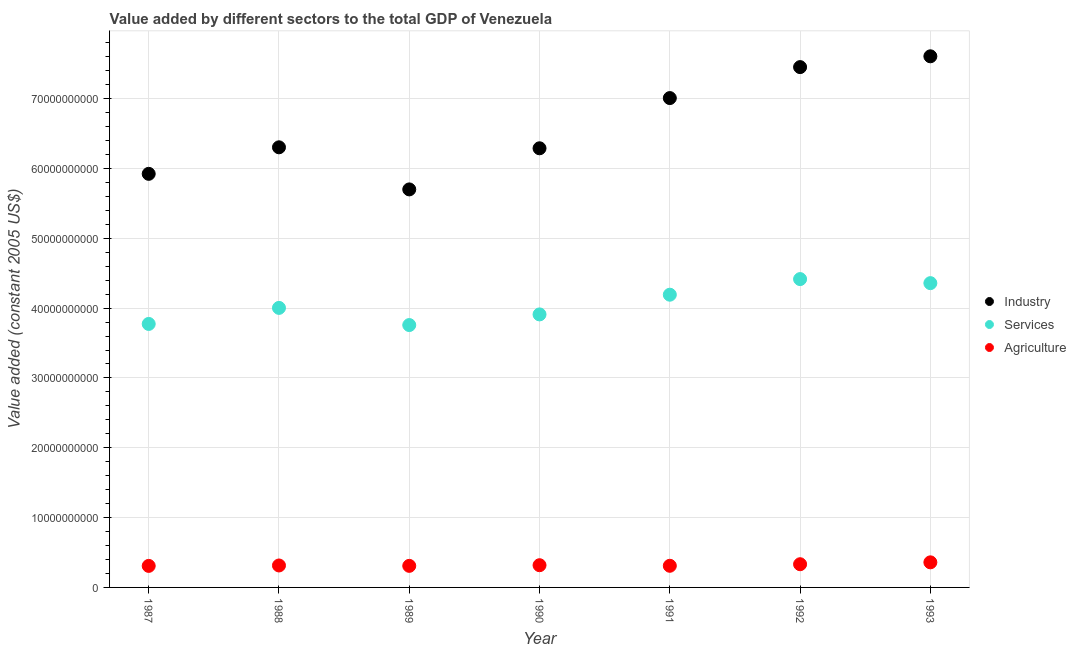How many different coloured dotlines are there?
Offer a very short reply. 3. What is the value added by agricultural sector in 1987?
Keep it short and to the point. 3.08e+09. Across all years, what is the maximum value added by services?
Provide a short and direct response. 4.42e+1. Across all years, what is the minimum value added by agricultural sector?
Provide a succinct answer. 3.08e+09. In which year was the value added by industrial sector maximum?
Give a very brief answer. 1993. In which year was the value added by agricultural sector minimum?
Give a very brief answer. 1987. What is the total value added by industrial sector in the graph?
Offer a terse response. 4.63e+11. What is the difference between the value added by agricultural sector in 1989 and that in 1992?
Make the answer very short. -2.34e+08. What is the difference between the value added by industrial sector in 1990 and the value added by agricultural sector in 1993?
Offer a terse response. 5.93e+1. What is the average value added by industrial sector per year?
Ensure brevity in your answer.  6.61e+1. In the year 1987, what is the difference between the value added by industrial sector and value added by services?
Offer a very short reply. 2.15e+1. What is the ratio of the value added by agricultural sector in 1991 to that in 1992?
Provide a short and direct response. 0.93. Is the value added by services in 1987 less than that in 1992?
Offer a terse response. Yes. What is the difference between the highest and the second highest value added by services?
Offer a very short reply. 5.81e+08. What is the difference between the highest and the lowest value added by services?
Provide a short and direct response. 6.58e+09. In how many years, is the value added by industrial sector greater than the average value added by industrial sector taken over all years?
Offer a terse response. 3. Is it the case that in every year, the sum of the value added by industrial sector and value added by services is greater than the value added by agricultural sector?
Provide a succinct answer. Yes. Is the value added by services strictly less than the value added by industrial sector over the years?
Give a very brief answer. Yes. How many years are there in the graph?
Offer a terse response. 7. Where does the legend appear in the graph?
Make the answer very short. Center right. How are the legend labels stacked?
Provide a succinct answer. Vertical. What is the title of the graph?
Make the answer very short. Value added by different sectors to the total GDP of Venezuela. What is the label or title of the X-axis?
Give a very brief answer. Year. What is the label or title of the Y-axis?
Provide a succinct answer. Value added (constant 2005 US$). What is the Value added (constant 2005 US$) of Industry in 1987?
Your response must be concise. 5.92e+1. What is the Value added (constant 2005 US$) in Services in 1987?
Ensure brevity in your answer.  3.77e+1. What is the Value added (constant 2005 US$) in Agriculture in 1987?
Offer a very short reply. 3.08e+09. What is the Value added (constant 2005 US$) of Industry in 1988?
Your response must be concise. 6.30e+1. What is the Value added (constant 2005 US$) in Services in 1988?
Make the answer very short. 4.00e+1. What is the Value added (constant 2005 US$) in Agriculture in 1988?
Offer a very short reply. 3.14e+09. What is the Value added (constant 2005 US$) in Industry in 1989?
Ensure brevity in your answer.  5.70e+1. What is the Value added (constant 2005 US$) in Services in 1989?
Offer a terse response. 3.76e+1. What is the Value added (constant 2005 US$) of Agriculture in 1989?
Offer a terse response. 3.09e+09. What is the Value added (constant 2005 US$) of Industry in 1990?
Your answer should be compact. 6.29e+1. What is the Value added (constant 2005 US$) in Services in 1990?
Offer a terse response. 3.91e+1. What is the Value added (constant 2005 US$) in Agriculture in 1990?
Your answer should be compact. 3.18e+09. What is the Value added (constant 2005 US$) of Industry in 1991?
Give a very brief answer. 7.01e+1. What is the Value added (constant 2005 US$) in Services in 1991?
Provide a short and direct response. 4.19e+1. What is the Value added (constant 2005 US$) of Agriculture in 1991?
Ensure brevity in your answer.  3.10e+09. What is the Value added (constant 2005 US$) in Industry in 1992?
Give a very brief answer. 7.45e+1. What is the Value added (constant 2005 US$) of Services in 1992?
Make the answer very short. 4.42e+1. What is the Value added (constant 2005 US$) of Agriculture in 1992?
Give a very brief answer. 3.32e+09. What is the Value added (constant 2005 US$) in Industry in 1993?
Make the answer very short. 7.61e+1. What is the Value added (constant 2005 US$) of Services in 1993?
Provide a succinct answer. 4.36e+1. What is the Value added (constant 2005 US$) of Agriculture in 1993?
Provide a short and direct response. 3.59e+09. Across all years, what is the maximum Value added (constant 2005 US$) of Industry?
Make the answer very short. 7.61e+1. Across all years, what is the maximum Value added (constant 2005 US$) in Services?
Offer a terse response. 4.42e+1. Across all years, what is the maximum Value added (constant 2005 US$) in Agriculture?
Your response must be concise. 3.59e+09. Across all years, what is the minimum Value added (constant 2005 US$) in Industry?
Ensure brevity in your answer.  5.70e+1. Across all years, what is the minimum Value added (constant 2005 US$) in Services?
Give a very brief answer. 3.76e+1. Across all years, what is the minimum Value added (constant 2005 US$) in Agriculture?
Your answer should be very brief. 3.08e+09. What is the total Value added (constant 2005 US$) of Industry in the graph?
Provide a short and direct response. 4.63e+11. What is the total Value added (constant 2005 US$) of Services in the graph?
Offer a very short reply. 2.84e+11. What is the total Value added (constant 2005 US$) in Agriculture in the graph?
Give a very brief answer. 2.25e+1. What is the difference between the Value added (constant 2005 US$) of Industry in 1987 and that in 1988?
Give a very brief answer. -3.80e+09. What is the difference between the Value added (constant 2005 US$) of Services in 1987 and that in 1988?
Offer a terse response. -2.30e+09. What is the difference between the Value added (constant 2005 US$) of Agriculture in 1987 and that in 1988?
Give a very brief answer. -6.05e+07. What is the difference between the Value added (constant 2005 US$) in Industry in 1987 and that in 1989?
Your answer should be compact. 2.23e+09. What is the difference between the Value added (constant 2005 US$) in Services in 1987 and that in 1989?
Provide a short and direct response. 1.60e+08. What is the difference between the Value added (constant 2005 US$) in Agriculture in 1987 and that in 1989?
Your response must be concise. -5.83e+06. What is the difference between the Value added (constant 2005 US$) in Industry in 1987 and that in 1990?
Give a very brief answer. -3.66e+09. What is the difference between the Value added (constant 2005 US$) of Services in 1987 and that in 1990?
Your response must be concise. -1.36e+09. What is the difference between the Value added (constant 2005 US$) of Agriculture in 1987 and that in 1990?
Give a very brief answer. -9.89e+07. What is the difference between the Value added (constant 2005 US$) of Industry in 1987 and that in 1991?
Give a very brief answer. -1.09e+1. What is the difference between the Value added (constant 2005 US$) of Services in 1987 and that in 1991?
Provide a short and direct response. -4.19e+09. What is the difference between the Value added (constant 2005 US$) of Agriculture in 1987 and that in 1991?
Offer a very short reply. -1.64e+07. What is the difference between the Value added (constant 2005 US$) of Industry in 1987 and that in 1992?
Provide a short and direct response. -1.53e+1. What is the difference between the Value added (constant 2005 US$) in Services in 1987 and that in 1992?
Your answer should be very brief. -6.42e+09. What is the difference between the Value added (constant 2005 US$) of Agriculture in 1987 and that in 1992?
Keep it short and to the point. -2.40e+08. What is the difference between the Value added (constant 2005 US$) of Industry in 1987 and that in 1993?
Your response must be concise. -1.68e+1. What is the difference between the Value added (constant 2005 US$) of Services in 1987 and that in 1993?
Your answer should be very brief. -5.84e+09. What is the difference between the Value added (constant 2005 US$) of Agriculture in 1987 and that in 1993?
Keep it short and to the point. -5.10e+08. What is the difference between the Value added (constant 2005 US$) in Industry in 1988 and that in 1989?
Your answer should be very brief. 6.03e+09. What is the difference between the Value added (constant 2005 US$) of Services in 1988 and that in 1989?
Give a very brief answer. 2.46e+09. What is the difference between the Value added (constant 2005 US$) of Agriculture in 1988 and that in 1989?
Your response must be concise. 5.47e+07. What is the difference between the Value added (constant 2005 US$) of Industry in 1988 and that in 1990?
Make the answer very short. 1.39e+08. What is the difference between the Value added (constant 2005 US$) in Services in 1988 and that in 1990?
Provide a succinct answer. 9.33e+08. What is the difference between the Value added (constant 2005 US$) of Agriculture in 1988 and that in 1990?
Make the answer very short. -3.84e+07. What is the difference between the Value added (constant 2005 US$) of Industry in 1988 and that in 1991?
Offer a very short reply. -7.05e+09. What is the difference between the Value added (constant 2005 US$) in Services in 1988 and that in 1991?
Your answer should be compact. -1.89e+09. What is the difference between the Value added (constant 2005 US$) in Agriculture in 1988 and that in 1991?
Keep it short and to the point. 4.41e+07. What is the difference between the Value added (constant 2005 US$) in Industry in 1988 and that in 1992?
Provide a short and direct response. -1.15e+1. What is the difference between the Value added (constant 2005 US$) of Services in 1988 and that in 1992?
Provide a short and direct response. -4.13e+09. What is the difference between the Value added (constant 2005 US$) of Agriculture in 1988 and that in 1992?
Give a very brief answer. -1.79e+08. What is the difference between the Value added (constant 2005 US$) of Industry in 1988 and that in 1993?
Keep it short and to the point. -1.30e+1. What is the difference between the Value added (constant 2005 US$) of Services in 1988 and that in 1993?
Offer a terse response. -3.55e+09. What is the difference between the Value added (constant 2005 US$) in Agriculture in 1988 and that in 1993?
Keep it short and to the point. -4.50e+08. What is the difference between the Value added (constant 2005 US$) of Industry in 1989 and that in 1990?
Keep it short and to the point. -5.89e+09. What is the difference between the Value added (constant 2005 US$) of Services in 1989 and that in 1990?
Keep it short and to the point. -1.52e+09. What is the difference between the Value added (constant 2005 US$) of Agriculture in 1989 and that in 1990?
Ensure brevity in your answer.  -9.31e+07. What is the difference between the Value added (constant 2005 US$) in Industry in 1989 and that in 1991?
Your answer should be very brief. -1.31e+1. What is the difference between the Value added (constant 2005 US$) in Services in 1989 and that in 1991?
Make the answer very short. -4.35e+09. What is the difference between the Value added (constant 2005 US$) in Agriculture in 1989 and that in 1991?
Give a very brief answer. -1.06e+07. What is the difference between the Value added (constant 2005 US$) in Industry in 1989 and that in 1992?
Your answer should be compact. -1.75e+1. What is the difference between the Value added (constant 2005 US$) of Services in 1989 and that in 1992?
Give a very brief answer. -6.58e+09. What is the difference between the Value added (constant 2005 US$) in Agriculture in 1989 and that in 1992?
Your answer should be very brief. -2.34e+08. What is the difference between the Value added (constant 2005 US$) in Industry in 1989 and that in 1993?
Your answer should be compact. -1.91e+1. What is the difference between the Value added (constant 2005 US$) in Services in 1989 and that in 1993?
Make the answer very short. -6.00e+09. What is the difference between the Value added (constant 2005 US$) in Agriculture in 1989 and that in 1993?
Your answer should be compact. -5.04e+08. What is the difference between the Value added (constant 2005 US$) in Industry in 1990 and that in 1991?
Keep it short and to the point. -7.19e+09. What is the difference between the Value added (constant 2005 US$) in Services in 1990 and that in 1991?
Provide a succinct answer. -2.82e+09. What is the difference between the Value added (constant 2005 US$) of Agriculture in 1990 and that in 1991?
Provide a short and direct response. 8.25e+07. What is the difference between the Value added (constant 2005 US$) in Industry in 1990 and that in 1992?
Your response must be concise. -1.16e+1. What is the difference between the Value added (constant 2005 US$) of Services in 1990 and that in 1992?
Provide a succinct answer. -5.06e+09. What is the difference between the Value added (constant 2005 US$) in Agriculture in 1990 and that in 1992?
Provide a succinct answer. -1.41e+08. What is the difference between the Value added (constant 2005 US$) in Industry in 1990 and that in 1993?
Ensure brevity in your answer.  -1.32e+1. What is the difference between the Value added (constant 2005 US$) in Services in 1990 and that in 1993?
Your response must be concise. -4.48e+09. What is the difference between the Value added (constant 2005 US$) in Agriculture in 1990 and that in 1993?
Make the answer very short. -4.11e+08. What is the difference between the Value added (constant 2005 US$) in Industry in 1991 and that in 1992?
Keep it short and to the point. -4.44e+09. What is the difference between the Value added (constant 2005 US$) in Services in 1991 and that in 1992?
Your answer should be very brief. -2.24e+09. What is the difference between the Value added (constant 2005 US$) of Agriculture in 1991 and that in 1992?
Your answer should be very brief. -2.24e+08. What is the difference between the Value added (constant 2005 US$) of Industry in 1991 and that in 1993?
Make the answer very short. -5.98e+09. What is the difference between the Value added (constant 2005 US$) of Services in 1991 and that in 1993?
Your answer should be very brief. -1.66e+09. What is the difference between the Value added (constant 2005 US$) of Agriculture in 1991 and that in 1993?
Your response must be concise. -4.94e+08. What is the difference between the Value added (constant 2005 US$) in Industry in 1992 and that in 1993?
Your response must be concise. -1.55e+09. What is the difference between the Value added (constant 2005 US$) in Services in 1992 and that in 1993?
Make the answer very short. 5.81e+08. What is the difference between the Value added (constant 2005 US$) of Agriculture in 1992 and that in 1993?
Offer a very short reply. -2.70e+08. What is the difference between the Value added (constant 2005 US$) of Industry in 1987 and the Value added (constant 2005 US$) of Services in 1988?
Ensure brevity in your answer.  1.92e+1. What is the difference between the Value added (constant 2005 US$) in Industry in 1987 and the Value added (constant 2005 US$) in Agriculture in 1988?
Provide a short and direct response. 5.61e+1. What is the difference between the Value added (constant 2005 US$) of Services in 1987 and the Value added (constant 2005 US$) of Agriculture in 1988?
Your answer should be very brief. 3.46e+1. What is the difference between the Value added (constant 2005 US$) in Industry in 1987 and the Value added (constant 2005 US$) in Services in 1989?
Ensure brevity in your answer.  2.17e+1. What is the difference between the Value added (constant 2005 US$) in Industry in 1987 and the Value added (constant 2005 US$) in Agriculture in 1989?
Your answer should be compact. 5.61e+1. What is the difference between the Value added (constant 2005 US$) of Services in 1987 and the Value added (constant 2005 US$) of Agriculture in 1989?
Ensure brevity in your answer.  3.46e+1. What is the difference between the Value added (constant 2005 US$) in Industry in 1987 and the Value added (constant 2005 US$) in Services in 1990?
Your response must be concise. 2.01e+1. What is the difference between the Value added (constant 2005 US$) in Industry in 1987 and the Value added (constant 2005 US$) in Agriculture in 1990?
Provide a short and direct response. 5.61e+1. What is the difference between the Value added (constant 2005 US$) in Services in 1987 and the Value added (constant 2005 US$) in Agriculture in 1990?
Keep it short and to the point. 3.46e+1. What is the difference between the Value added (constant 2005 US$) in Industry in 1987 and the Value added (constant 2005 US$) in Services in 1991?
Make the answer very short. 1.73e+1. What is the difference between the Value added (constant 2005 US$) of Industry in 1987 and the Value added (constant 2005 US$) of Agriculture in 1991?
Give a very brief answer. 5.61e+1. What is the difference between the Value added (constant 2005 US$) of Services in 1987 and the Value added (constant 2005 US$) of Agriculture in 1991?
Ensure brevity in your answer.  3.46e+1. What is the difference between the Value added (constant 2005 US$) of Industry in 1987 and the Value added (constant 2005 US$) of Services in 1992?
Your response must be concise. 1.51e+1. What is the difference between the Value added (constant 2005 US$) of Industry in 1987 and the Value added (constant 2005 US$) of Agriculture in 1992?
Keep it short and to the point. 5.59e+1. What is the difference between the Value added (constant 2005 US$) of Services in 1987 and the Value added (constant 2005 US$) of Agriculture in 1992?
Provide a short and direct response. 3.44e+1. What is the difference between the Value added (constant 2005 US$) in Industry in 1987 and the Value added (constant 2005 US$) in Services in 1993?
Offer a very short reply. 1.57e+1. What is the difference between the Value added (constant 2005 US$) of Industry in 1987 and the Value added (constant 2005 US$) of Agriculture in 1993?
Provide a succinct answer. 5.56e+1. What is the difference between the Value added (constant 2005 US$) of Services in 1987 and the Value added (constant 2005 US$) of Agriculture in 1993?
Give a very brief answer. 3.41e+1. What is the difference between the Value added (constant 2005 US$) of Industry in 1988 and the Value added (constant 2005 US$) of Services in 1989?
Your answer should be compact. 2.55e+1. What is the difference between the Value added (constant 2005 US$) in Industry in 1988 and the Value added (constant 2005 US$) in Agriculture in 1989?
Your response must be concise. 5.99e+1. What is the difference between the Value added (constant 2005 US$) in Services in 1988 and the Value added (constant 2005 US$) in Agriculture in 1989?
Keep it short and to the point. 3.69e+1. What is the difference between the Value added (constant 2005 US$) in Industry in 1988 and the Value added (constant 2005 US$) in Services in 1990?
Offer a very short reply. 2.39e+1. What is the difference between the Value added (constant 2005 US$) of Industry in 1988 and the Value added (constant 2005 US$) of Agriculture in 1990?
Provide a short and direct response. 5.99e+1. What is the difference between the Value added (constant 2005 US$) of Services in 1988 and the Value added (constant 2005 US$) of Agriculture in 1990?
Offer a terse response. 3.69e+1. What is the difference between the Value added (constant 2005 US$) in Industry in 1988 and the Value added (constant 2005 US$) in Services in 1991?
Ensure brevity in your answer.  2.11e+1. What is the difference between the Value added (constant 2005 US$) in Industry in 1988 and the Value added (constant 2005 US$) in Agriculture in 1991?
Your answer should be compact. 5.99e+1. What is the difference between the Value added (constant 2005 US$) in Services in 1988 and the Value added (constant 2005 US$) in Agriculture in 1991?
Offer a terse response. 3.69e+1. What is the difference between the Value added (constant 2005 US$) of Industry in 1988 and the Value added (constant 2005 US$) of Services in 1992?
Offer a terse response. 1.89e+1. What is the difference between the Value added (constant 2005 US$) in Industry in 1988 and the Value added (constant 2005 US$) in Agriculture in 1992?
Ensure brevity in your answer.  5.97e+1. What is the difference between the Value added (constant 2005 US$) of Services in 1988 and the Value added (constant 2005 US$) of Agriculture in 1992?
Your answer should be compact. 3.67e+1. What is the difference between the Value added (constant 2005 US$) in Industry in 1988 and the Value added (constant 2005 US$) in Services in 1993?
Your answer should be compact. 1.95e+1. What is the difference between the Value added (constant 2005 US$) of Industry in 1988 and the Value added (constant 2005 US$) of Agriculture in 1993?
Your answer should be very brief. 5.94e+1. What is the difference between the Value added (constant 2005 US$) in Services in 1988 and the Value added (constant 2005 US$) in Agriculture in 1993?
Provide a succinct answer. 3.64e+1. What is the difference between the Value added (constant 2005 US$) of Industry in 1989 and the Value added (constant 2005 US$) of Services in 1990?
Your answer should be compact. 1.79e+1. What is the difference between the Value added (constant 2005 US$) in Industry in 1989 and the Value added (constant 2005 US$) in Agriculture in 1990?
Offer a very short reply. 5.38e+1. What is the difference between the Value added (constant 2005 US$) in Services in 1989 and the Value added (constant 2005 US$) in Agriculture in 1990?
Your answer should be very brief. 3.44e+1. What is the difference between the Value added (constant 2005 US$) in Industry in 1989 and the Value added (constant 2005 US$) in Services in 1991?
Make the answer very short. 1.51e+1. What is the difference between the Value added (constant 2005 US$) of Industry in 1989 and the Value added (constant 2005 US$) of Agriculture in 1991?
Provide a short and direct response. 5.39e+1. What is the difference between the Value added (constant 2005 US$) in Services in 1989 and the Value added (constant 2005 US$) in Agriculture in 1991?
Make the answer very short. 3.45e+1. What is the difference between the Value added (constant 2005 US$) of Industry in 1989 and the Value added (constant 2005 US$) of Services in 1992?
Your answer should be compact. 1.28e+1. What is the difference between the Value added (constant 2005 US$) of Industry in 1989 and the Value added (constant 2005 US$) of Agriculture in 1992?
Provide a succinct answer. 5.37e+1. What is the difference between the Value added (constant 2005 US$) in Services in 1989 and the Value added (constant 2005 US$) in Agriculture in 1992?
Make the answer very short. 3.43e+1. What is the difference between the Value added (constant 2005 US$) in Industry in 1989 and the Value added (constant 2005 US$) in Services in 1993?
Make the answer very short. 1.34e+1. What is the difference between the Value added (constant 2005 US$) of Industry in 1989 and the Value added (constant 2005 US$) of Agriculture in 1993?
Offer a terse response. 5.34e+1. What is the difference between the Value added (constant 2005 US$) in Services in 1989 and the Value added (constant 2005 US$) in Agriculture in 1993?
Ensure brevity in your answer.  3.40e+1. What is the difference between the Value added (constant 2005 US$) in Industry in 1990 and the Value added (constant 2005 US$) in Services in 1991?
Make the answer very short. 2.10e+1. What is the difference between the Value added (constant 2005 US$) in Industry in 1990 and the Value added (constant 2005 US$) in Agriculture in 1991?
Your response must be concise. 5.98e+1. What is the difference between the Value added (constant 2005 US$) in Services in 1990 and the Value added (constant 2005 US$) in Agriculture in 1991?
Keep it short and to the point. 3.60e+1. What is the difference between the Value added (constant 2005 US$) in Industry in 1990 and the Value added (constant 2005 US$) in Services in 1992?
Your answer should be compact. 1.87e+1. What is the difference between the Value added (constant 2005 US$) of Industry in 1990 and the Value added (constant 2005 US$) of Agriculture in 1992?
Offer a terse response. 5.96e+1. What is the difference between the Value added (constant 2005 US$) of Services in 1990 and the Value added (constant 2005 US$) of Agriculture in 1992?
Your response must be concise. 3.58e+1. What is the difference between the Value added (constant 2005 US$) in Industry in 1990 and the Value added (constant 2005 US$) in Services in 1993?
Provide a short and direct response. 1.93e+1. What is the difference between the Value added (constant 2005 US$) of Industry in 1990 and the Value added (constant 2005 US$) of Agriculture in 1993?
Your answer should be compact. 5.93e+1. What is the difference between the Value added (constant 2005 US$) in Services in 1990 and the Value added (constant 2005 US$) in Agriculture in 1993?
Make the answer very short. 3.55e+1. What is the difference between the Value added (constant 2005 US$) of Industry in 1991 and the Value added (constant 2005 US$) of Services in 1992?
Provide a short and direct response. 2.59e+1. What is the difference between the Value added (constant 2005 US$) of Industry in 1991 and the Value added (constant 2005 US$) of Agriculture in 1992?
Your answer should be very brief. 6.68e+1. What is the difference between the Value added (constant 2005 US$) of Services in 1991 and the Value added (constant 2005 US$) of Agriculture in 1992?
Ensure brevity in your answer.  3.86e+1. What is the difference between the Value added (constant 2005 US$) of Industry in 1991 and the Value added (constant 2005 US$) of Services in 1993?
Your answer should be compact. 2.65e+1. What is the difference between the Value added (constant 2005 US$) of Industry in 1991 and the Value added (constant 2005 US$) of Agriculture in 1993?
Keep it short and to the point. 6.65e+1. What is the difference between the Value added (constant 2005 US$) in Services in 1991 and the Value added (constant 2005 US$) in Agriculture in 1993?
Your answer should be compact. 3.83e+1. What is the difference between the Value added (constant 2005 US$) of Industry in 1992 and the Value added (constant 2005 US$) of Services in 1993?
Give a very brief answer. 3.09e+1. What is the difference between the Value added (constant 2005 US$) in Industry in 1992 and the Value added (constant 2005 US$) in Agriculture in 1993?
Provide a succinct answer. 7.09e+1. What is the difference between the Value added (constant 2005 US$) of Services in 1992 and the Value added (constant 2005 US$) of Agriculture in 1993?
Your answer should be compact. 4.06e+1. What is the average Value added (constant 2005 US$) in Industry per year?
Give a very brief answer. 6.61e+1. What is the average Value added (constant 2005 US$) of Services per year?
Keep it short and to the point. 4.06e+1. What is the average Value added (constant 2005 US$) of Agriculture per year?
Offer a terse response. 3.22e+09. In the year 1987, what is the difference between the Value added (constant 2005 US$) in Industry and Value added (constant 2005 US$) in Services?
Offer a very short reply. 2.15e+1. In the year 1987, what is the difference between the Value added (constant 2005 US$) in Industry and Value added (constant 2005 US$) in Agriculture?
Your response must be concise. 5.62e+1. In the year 1987, what is the difference between the Value added (constant 2005 US$) of Services and Value added (constant 2005 US$) of Agriculture?
Offer a terse response. 3.47e+1. In the year 1988, what is the difference between the Value added (constant 2005 US$) of Industry and Value added (constant 2005 US$) of Services?
Provide a short and direct response. 2.30e+1. In the year 1988, what is the difference between the Value added (constant 2005 US$) in Industry and Value added (constant 2005 US$) in Agriculture?
Provide a short and direct response. 5.99e+1. In the year 1988, what is the difference between the Value added (constant 2005 US$) in Services and Value added (constant 2005 US$) in Agriculture?
Keep it short and to the point. 3.69e+1. In the year 1989, what is the difference between the Value added (constant 2005 US$) in Industry and Value added (constant 2005 US$) in Services?
Make the answer very short. 1.94e+1. In the year 1989, what is the difference between the Value added (constant 2005 US$) of Industry and Value added (constant 2005 US$) of Agriculture?
Your answer should be compact. 5.39e+1. In the year 1989, what is the difference between the Value added (constant 2005 US$) in Services and Value added (constant 2005 US$) in Agriculture?
Provide a short and direct response. 3.45e+1. In the year 1990, what is the difference between the Value added (constant 2005 US$) in Industry and Value added (constant 2005 US$) in Services?
Make the answer very short. 2.38e+1. In the year 1990, what is the difference between the Value added (constant 2005 US$) of Industry and Value added (constant 2005 US$) of Agriculture?
Give a very brief answer. 5.97e+1. In the year 1990, what is the difference between the Value added (constant 2005 US$) in Services and Value added (constant 2005 US$) in Agriculture?
Provide a short and direct response. 3.59e+1. In the year 1991, what is the difference between the Value added (constant 2005 US$) in Industry and Value added (constant 2005 US$) in Services?
Ensure brevity in your answer.  2.82e+1. In the year 1991, what is the difference between the Value added (constant 2005 US$) of Industry and Value added (constant 2005 US$) of Agriculture?
Make the answer very short. 6.70e+1. In the year 1991, what is the difference between the Value added (constant 2005 US$) in Services and Value added (constant 2005 US$) in Agriculture?
Give a very brief answer. 3.88e+1. In the year 1992, what is the difference between the Value added (constant 2005 US$) of Industry and Value added (constant 2005 US$) of Services?
Keep it short and to the point. 3.04e+1. In the year 1992, what is the difference between the Value added (constant 2005 US$) in Industry and Value added (constant 2005 US$) in Agriculture?
Give a very brief answer. 7.12e+1. In the year 1992, what is the difference between the Value added (constant 2005 US$) of Services and Value added (constant 2005 US$) of Agriculture?
Your answer should be compact. 4.08e+1. In the year 1993, what is the difference between the Value added (constant 2005 US$) in Industry and Value added (constant 2005 US$) in Services?
Give a very brief answer. 3.25e+1. In the year 1993, what is the difference between the Value added (constant 2005 US$) in Industry and Value added (constant 2005 US$) in Agriculture?
Make the answer very short. 7.25e+1. In the year 1993, what is the difference between the Value added (constant 2005 US$) of Services and Value added (constant 2005 US$) of Agriculture?
Keep it short and to the point. 4.00e+1. What is the ratio of the Value added (constant 2005 US$) in Industry in 1987 to that in 1988?
Give a very brief answer. 0.94. What is the ratio of the Value added (constant 2005 US$) in Services in 1987 to that in 1988?
Keep it short and to the point. 0.94. What is the ratio of the Value added (constant 2005 US$) in Agriculture in 1987 to that in 1988?
Your answer should be compact. 0.98. What is the ratio of the Value added (constant 2005 US$) of Industry in 1987 to that in 1989?
Make the answer very short. 1.04. What is the ratio of the Value added (constant 2005 US$) of Services in 1987 to that in 1989?
Make the answer very short. 1. What is the ratio of the Value added (constant 2005 US$) in Industry in 1987 to that in 1990?
Your answer should be very brief. 0.94. What is the ratio of the Value added (constant 2005 US$) in Services in 1987 to that in 1990?
Your answer should be compact. 0.97. What is the ratio of the Value added (constant 2005 US$) of Agriculture in 1987 to that in 1990?
Make the answer very short. 0.97. What is the ratio of the Value added (constant 2005 US$) of Industry in 1987 to that in 1991?
Ensure brevity in your answer.  0.85. What is the ratio of the Value added (constant 2005 US$) in Services in 1987 to that in 1991?
Give a very brief answer. 0.9. What is the ratio of the Value added (constant 2005 US$) of Industry in 1987 to that in 1992?
Your response must be concise. 0.79. What is the ratio of the Value added (constant 2005 US$) in Services in 1987 to that in 1992?
Your response must be concise. 0.85. What is the ratio of the Value added (constant 2005 US$) in Agriculture in 1987 to that in 1992?
Ensure brevity in your answer.  0.93. What is the ratio of the Value added (constant 2005 US$) in Industry in 1987 to that in 1993?
Keep it short and to the point. 0.78. What is the ratio of the Value added (constant 2005 US$) in Services in 1987 to that in 1993?
Your response must be concise. 0.87. What is the ratio of the Value added (constant 2005 US$) of Agriculture in 1987 to that in 1993?
Provide a short and direct response. 0.86. What is the ratio of the Value added (constant 2005 US$) of Industry in 1988 to that in 1989?
Offer a terse response. 1.11. What is the ratio of the Value added (constant 2005 US$) of Services in 1988 to that in 1989?
Your answer should be very brief. 1.07. What is the ratio of the Value added (constant 2005 US$) in Agriculture in 1988 to that in 1989?
Give a very brief answer. 1.02. What is the ratio of the Value added (constant 2005 US$) of Services in 1988 to that in 1990?
Provide a short and direct response. 1.02. What is the ratio of the Value added (constant 2005 US$) of Agriculture in 1988 to that in 1990?
Ensure brevity in your answer.  0.99. What is the ratio of the Value added (constant 2005 US$) of Industry in 1988 to that in 1991?
Keep it short and to the point. 0.9. What is the ratio of the Value added (constant 2005 US$) of Services in 1988 to that in 1991?
Your response must be concise. 0.95. What is the ratio of the Value added (constant 2005 US$) of Agriculture in 1988 to that in 1991?
Ensure brevity in your answer.  1.01. What is the ratio of the Value added (constant 2005 US$) of Industry in 1988 to that in 1992?
Your answer should be very brief. 0.85. What is the ratio of the Value added (constant 2005 US$) of Services in 1988 to that in 1992?
Keep it short and to the point. 0.91. What is the ratio of the Value added (constant 2005 US$) of Agriculture in 1988 to that in 1992?
Your answer should be compact. 0.95. What is the ratio of the Value added (constant 2005 US$) in Industry in 1988 to that in 1993?
Offer a very short reply. 0.83. What is the ratio of the Value added (constant 2005 US$) in Services in 1988 to that in 1993?
Ensure brevity in your answer.  0.92. What is the ratio of the Value added (constant 2005 US$) of Agriculture in 1988 to that in 1993?
Ensure brevity in your answer.  0.87. What is the ratio of the Value added (constant 2005 US$) of Industry in 1989 to that in 1990?
Keep it short and to the point. 0.91. What is the ratio of the Value added (constant 2005 US$) in Services in 1989 to that in 1990?
Provide a short and direct response. 0.96. What is the ratio of the Value added (constant 2005 US$) of Agriculture in 1989 to that in 1990?
Your answer should be very brief. 0.97. What is the ratio of the Value added (constant 2005 US$) in Industry in 1989 to that in 1991?
Your answer should be very brief. 0.81. What is the ratio of the Value added (constant 2005 US$) in Services in 1989 to that in 1991?
Your response must be concise. 0.9. What is the ratio of the Value added (constant 2005 US$) in Industry in 1989 to that in 1992?
Give a very brief answer. 0.77. What is the ratio of the Value added (constant 2005 US$) in Services in 1989 to that in 1992?
Your response must be concise. 0.85. What is the ratio of the Value added (constant 2005 US$) in Agriculture in 1989 to that in 1992?
Give a very brief answer. 0.93. What is the ratio of the Value added (constant 2005 US$) in Industry in 1989 to that in 1993?
Your answer should be compact. 0.75. What is the ratio of the Value added (constant 2005 US$) in Services in 1989 to that in 1993?
Your answer should be very brief. 0.86. What is the ratio of the Value added (constant 2005 US$) of Agriculture in 1989 to that in 1993?
Provide a succinct answer. 0.86. What is the ratio of the Value added (constant 2005 US$) in Industry in 1990 to that in 1991?
Keep it short and to the point. 0.9. What is the ratio of the Value added (constant 2005 US$) in Services in 1990 to that in 1991?
Keep it short and to the point. 0.93. What is the ratio of the Value added (constant 2005 US$) in Agriculture in 1990 to that in 1991?
Provide a succinct answer. 1.03. What is the ratio of the Value added (constant 2005 US$) of Industry in 1990 to that in 1992?
Your answer should be compact. 0.84. What is the ratio of the Value added (constant 2005 US$) of Services in 1990 to that in 1992?
Provide a succinct answer. 0.89. What is the ratio of the Value added (constant 2005 US$) of Agriculture in 1990 to that in 1992?
Keep it short and to the point. 0.96. What is the ratio of the Value added (constant 2005 US$) of Industry in 1990 to that in 1993?
Keep it short and to the point. 0.83. What is the ratio of the Value added (constant 2005 US$) of Services in 1990 to that in 1993?
Keep it short and to the point. 0.9. What is the ratio of the Value added (constant 2005 US$) of Agriculture in 1990 to that in 1993?
Keep it short and to the point. 0.89. What is the ratio of the Value added (constant 2005 US$) in Industry in 1991 to that in 1992?
Give a very brief answer. 0.94. What is the ratio of the Value added (constant 2005 US$) of Services in 1991 to that in 1992?
Give a very brief answer. 0.95. What is the ratio of the Value added (constant 2005 US$) in Agriculture in 1991 to that in 1992?
Give a very brief answer. 0.93. What is the ratio of the Value added (constant 2005 US$) in Industry in 1991 to that in 1993?
Make the answer very short. 0.92. What is the ratio of the Value added (constant 2005 US$) in Agriculture in 1991 to that in 1993?
Keep it short and to the point. 0.86. What is the ratio of the Value added (constant 2005 US$) of Industry in 1992 to that in 1993?
Offer a very short reply. 0.98. What is the ratio of the Value added (constant 2005 US$) of Services in 1992 to that in 1993?
Keep it short and to the point. 1.01. What is the ratio of the Value added (constant 2005 US$) of Agriculture in 1992 to that in 1993?
Give a very brief answer. 0.92. What is the difference between the highest and the second highest Value added (constant 2005 US$) in Industry?
Offer a very short reply. 1.55e+09. What is the difference between the highest and the second highest Value added (constant 2005 US$) of Services?
Ensure brevity in your answer.  5.81e+08. What is the difference between the highest and the second highest Value added (constant 2005 US$) of Agriculture?
Offer a very short reply. 2.70e+08. What is the difference between the highest and the lowest Value added (constant 2005 US$) in Industry?
Keep it short and to the point. 1.91e+1. What is the difference between the highest and the lowest Value added (constant 2005 US$) of Services?
Offer a very short reply. 6.58e+09. What is the difference between the highest and the lowest Value added (constant 2005 US$) of Agriculture?
Provide a succinct answer. 5.10e+08. 